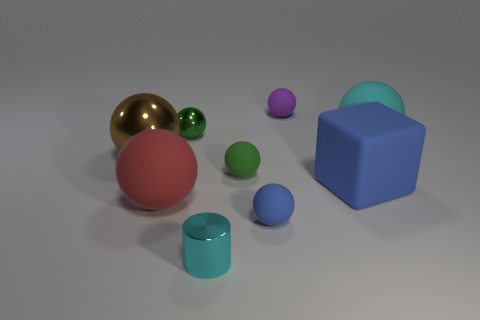Subtract all rubber spheres. How many spheres are left? 2 Subtract all blue spheres. How many spheres are left? 6 Subtract all brown cylinders. How many yellow cubes are left? 0 Add 4 big red spheres. How many big red spheres are left? 5 Add 7 large gray shiny balls. How many large gray shiny balls exist? 7 Subtract 2 green balls. How many objects are left? 7 Subtract all cylinders. How many objects are left? 8 Subtract 1 cylinders. How many cylinders are left? 0 Subtract all purple cylinders. Subtract all yellow balls. How many cylinders are left? 1 Subtract all brown shiny balls. Subtract all big things. How many objects are left? 4 